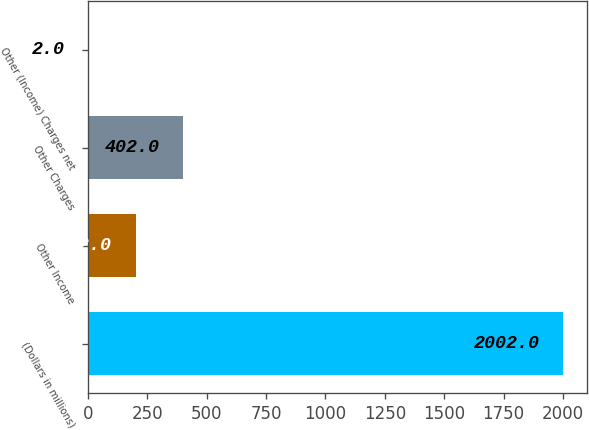Convert chart. <chart><loc_0><loc_0><loc_500><loc_500><bar_chart><fcel>(Dollars in millions)<fcel>Other Income<fcel>Other Charges<fcel>Other (Income) Charges net<nl><fcel>2002<fcel>202<fcel>402<fcel>2<nl></chart> 